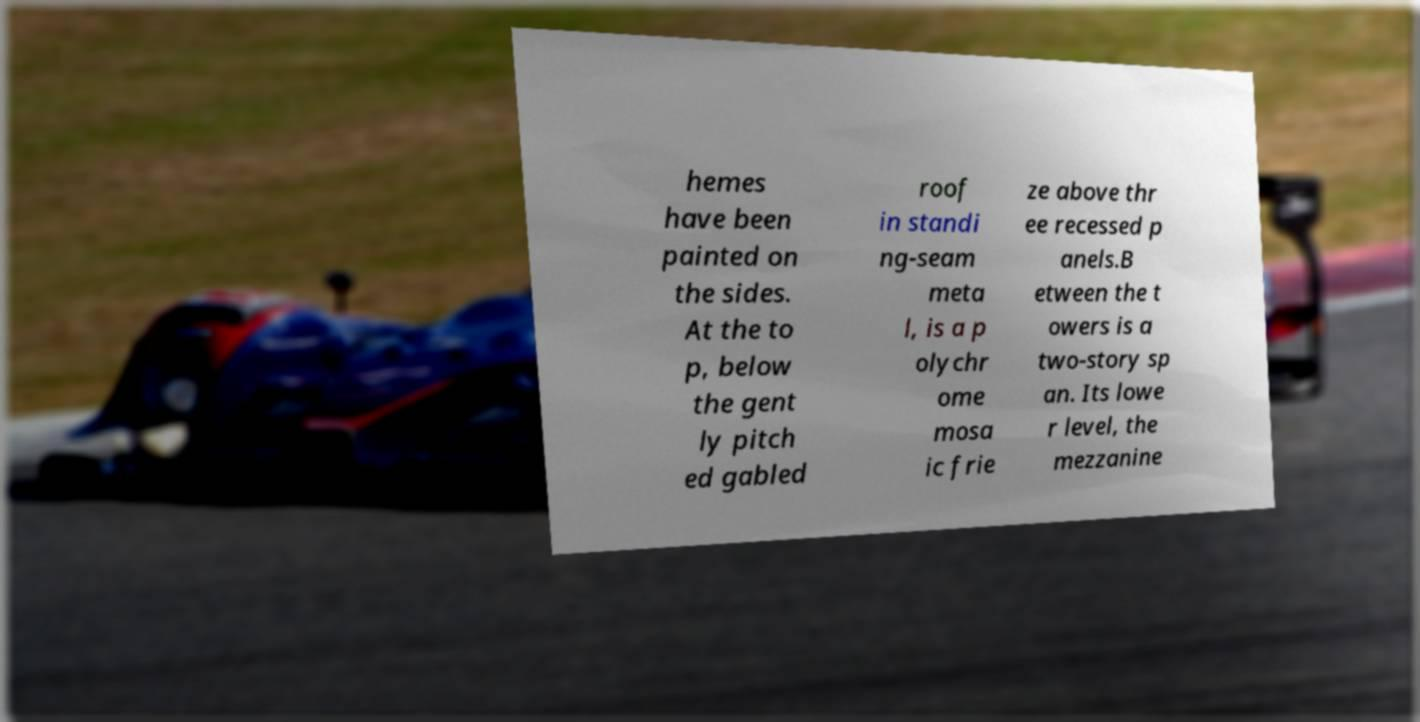Could you assist in decoding the text presented in this image and type it out clearly? hemes have been painted on the sides. At the to p, below the gent ly pitch ed gabled roof in standi ng-seam meta l, is a p olychr ome mosa ic frie ze above thr ee recessed p anels.B etween the t owers is a two-story sp an. Its lowe r level, the mezzanine 